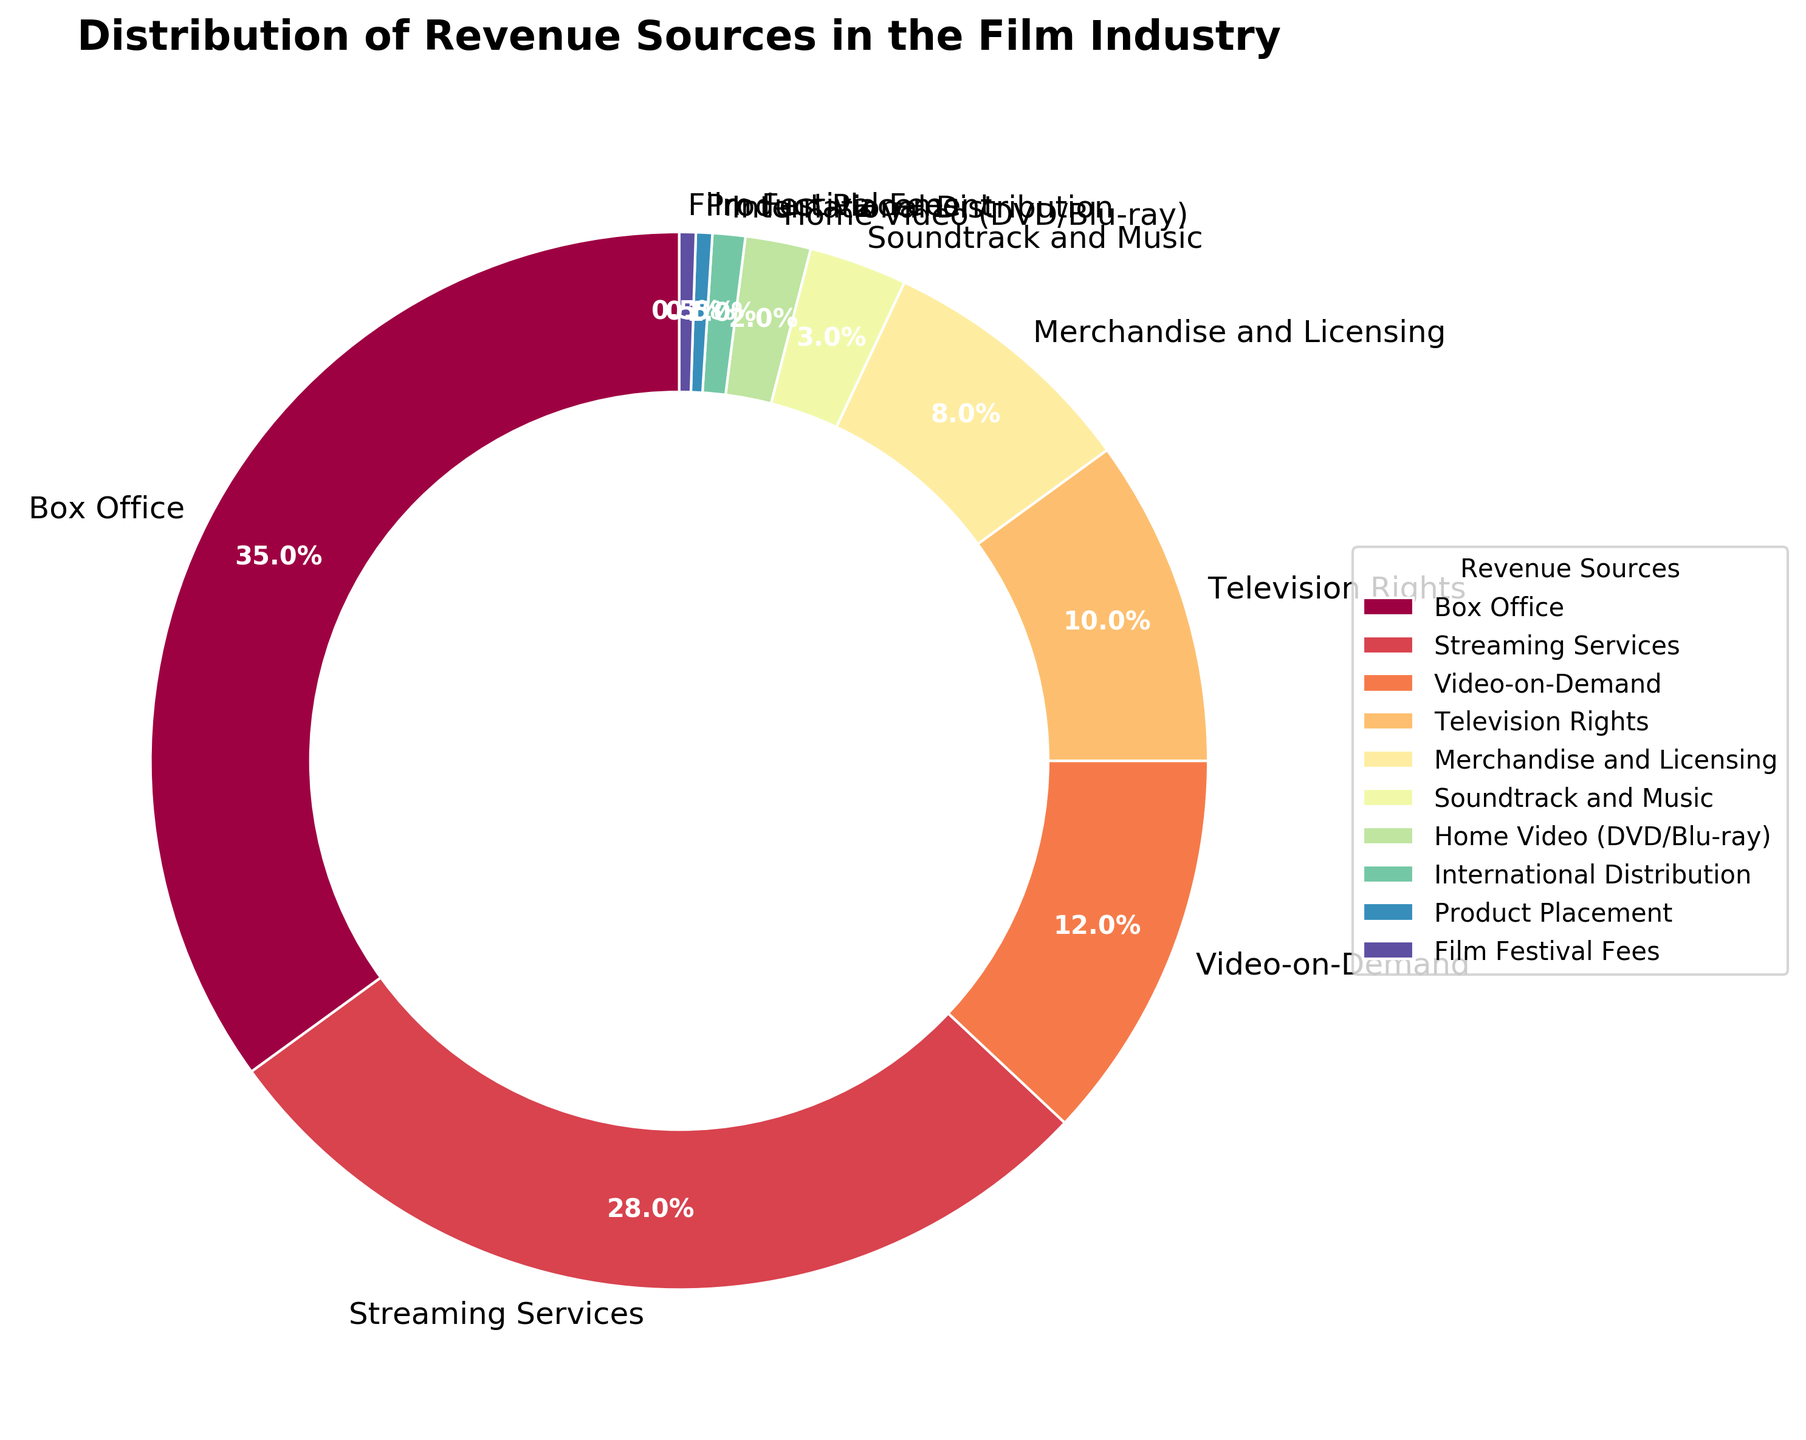Which revenue source contributes the highest percentage to the total revenue? The pie chart shows that the revenue source with the largest slice is the box office, contributing 35%.
Answer: Box Office What's the combined revenue percentage of Box Office and Streaming Services? According to the pie chart, the box office contributes 35% and streaming services contribute 28%. Combining these, 35% + 28% = 63%.
Answer: 63% Which sources contribute equally to the revenue and what is their combined percentage? The sources that both contribute 0.5% each are product placement and film festival fees. Their combined percentage is 0.5% + 0.5% = 1%.
Answer: Product Placement and Film Festival Fees, 1% How does the revenue percentage from merchandise and licensing compare to that from television rights? Merchandise and licensing contribute 8% whereas television rights contribute 10%. Television rights have a 2% higher revenue contribution.
Answer: Television Rights, 10% Which source has the lowest revenue contribution and what is its percentage? The smallest slice in the pie chart corresponds to product placement and film festival fees, both contributing 0.5%.
Answer: Product Placement and Film Festival Fees, 0.5% What's the total revenue percentage from sources contributing less than 5%? The sources with less than 5% contribution are soundtrack and music (3%), home video (2%), international distribution (1%), product placement (0.5%), and film festival fees (0.5%). Adding these, 3% + 2% + 1% + 0.5% + 0.5% = 7%.
Answer: 7% How much more does streaming services contribute compared to video-on-demand? Streaming services cover 28% while video-on-demand accounts for 12%. The difference is 28% - 12% = 16%.
Answer: 16% What percentage of revenue comes from home video and soundtrack and music combined? Home video contributes 2%, and soundtrack and music contribute 3%. Together, they add up to 2% + 3% = 5%.
Answer: 5% Which revenue source’s percentage is closest to the average contribution of all sources? To find the average, sum all percentages and divide by the number of sources: (35 + 28 + 12 + 10 + 8 + 3 + 2 + 1 + 0.5 + 0.5) / 10 = 10%. The revenue source closest to this average is television rights, which is exactly 10%.
Answer: Television Rights, 10% 